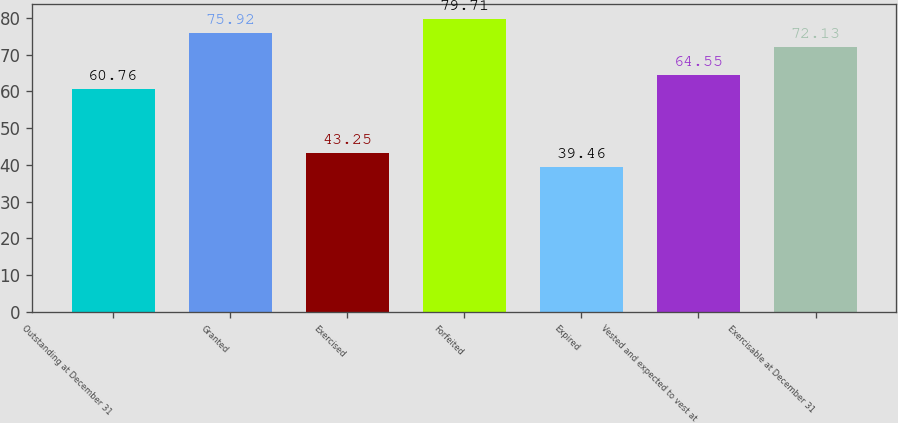Convert chart to OTSL. <chart><loc_0><loc_0><loc_500><loc_500><bar_chart><fcel>Outstanding at December 31<fcel>Granted<fcel>Exercised<fcel>Forfeited<fcel>Expired<fcel>Vested and expected to vest at<fcel>Exercisable at December 31<nl><fcel>60.76<fcel>75.92<fcel>43.25<fcel>79.71<fcel>39.46<fcel>64.55<fcel>72.13<nl></chart> 